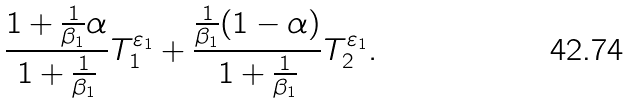<formula> <loc_0><loc_0><loc_500><loc_500>\frac { 1 + \frac { 1 } { \beta _ { 1 } } \alpha } { 1 + \frac { 1 } { \beta _ { 1 } } } T _ { 1 } ^ { \varepsilon _ { 1 } } + \frac { \frac { 1 } { \beta _ { 1 } } ( 1 - \alpha ) } { 1 + \frac { 1 } { \beta _ { 1 } } } T _ { 2 } ^ { \varepsilon _ { 1 } } .</formula> 